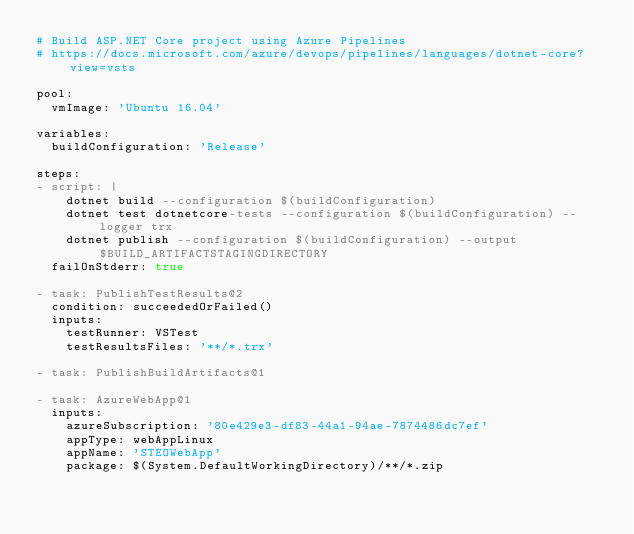<code> <loc_0><loc_0><loc_500><loc_500><_YAML_># Build ASP.NET Core project using Azure Pipelines
# https://docs.microsoft.com/azure/devops/pipelines/languages/dotnet-core?view=vsts

pool:
  vmImage: 'Ubuntu 16.04'
  
variables:
  buildConfiguration: 'Release'

steps:
- script: |
    dotnet build --configuration $(buildConfiguration)
    dotnet test dotnetcore-tests --configuration $(buildConfiguration) --logger trx
    dotnet publish --configuration $(buildConfiguration) --output $BUILD_ARTIFACTSTAGINGDIRECTORY
  failOnStderr: true

- task: PublishTestResults@2
  condition: succeededOrFailed()
  inputs:
    testRunner: VSTest
    testResultsFiles: '**/*.trx'

- task: PublishBuildArtifacts@1

- task: AzureWebApp@1
  inputs:
    azureSubscription: '80e429e3-df83-44a1-94ae-7874486dc7ef'
    appType: webAppLinux
    appName: 'STEOWebApp'
    package: $(System.DefaultWorkingDirectory)/**/*.zip</code> 